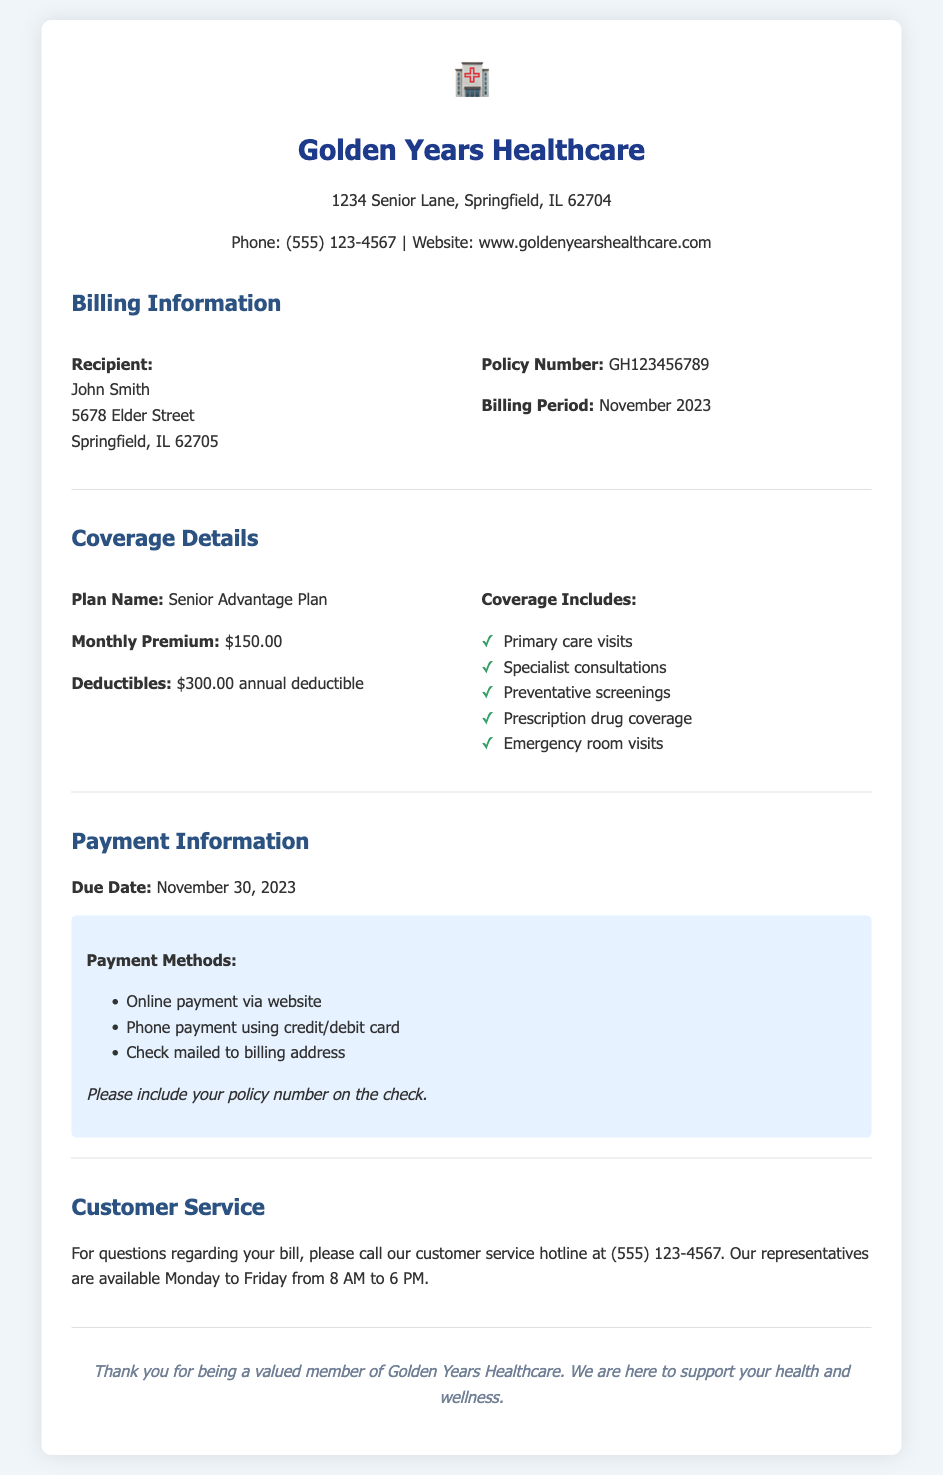What is the billing period? The billing period is specified in the document under Billing Information as November 2023.
Answer: November 2023 What is the plan name? The plan name is noted in the Coverage Details section as Senior Advantage Plan.
Answer: Senior Advantage Plan What is the monthly premium? The monthly premium is stated in the Coverage Details section as $150.00.
Answer: $150.00 What is the due date for the payment? The due date is mentioned in the Payment Information section as November 30, 2023.
Answer: November 30, 2023 How many points are listed under "Coverage Includes"? The list under Coverage Includes contains five items, as seen in the Coverage Details section.
Answer: 5 What are the payment methods available? The document lists three options for payment methods in the Payment Information section, including online payment, phone payment, and mailed check.
Answer: Online payment, Phone payment, Check What should you include on the mailed check? The document specifies that you should include your policy number on the check.
Answer: Policy number What are the customer service hours? The customer service hours are detailed as being available Monday to Friday from 8 AM to 6 PM.
Answer: 8 AM to 6 PM 